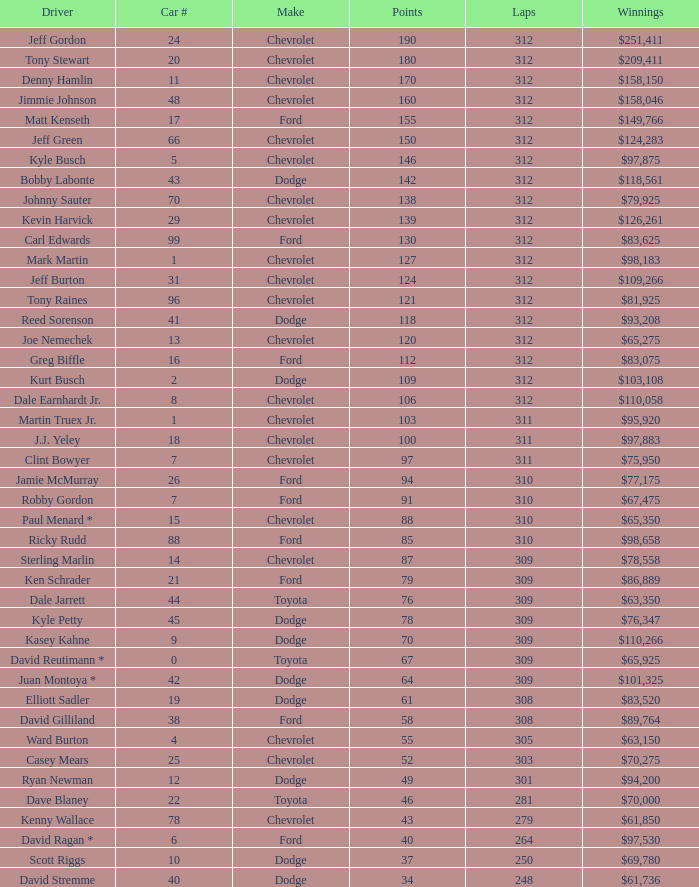What is the least number of laps for kyle petty with under 118 points? 309.0. 